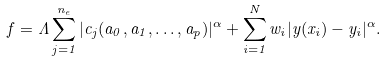<formula> <loc_0><loc_0><loc_500><loc_500>f = \Lambda \sum _ { j = 1 } ^ { n _ { e } } | c _ { j } ( a _ { 0 } , a _ { 1 } , \dots , a _ { p } ) | ^ { \alpha } + \sum _ { i = 1 } ^ { N } w _ { i } | y ( x _ { i } ) - y _ { i } | ^ { \alpha } .</formula> 